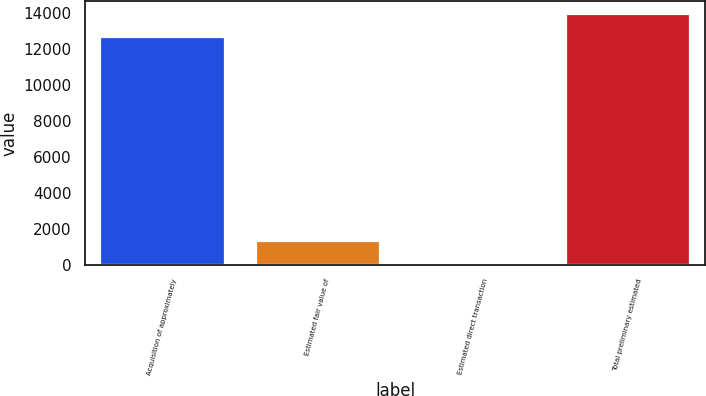<chart> <loc_0><loc_0><loc_500><loc_500><bar_chart><fcel>Acquisition of approximately<fcel>Estimated fair value of<fcel>Estimated direct transaction<fcel>Total preliminary estimated<nl><fcel>12670<fcel>1333.8<fcel>34<fcel>13969.8<nl></chart> 